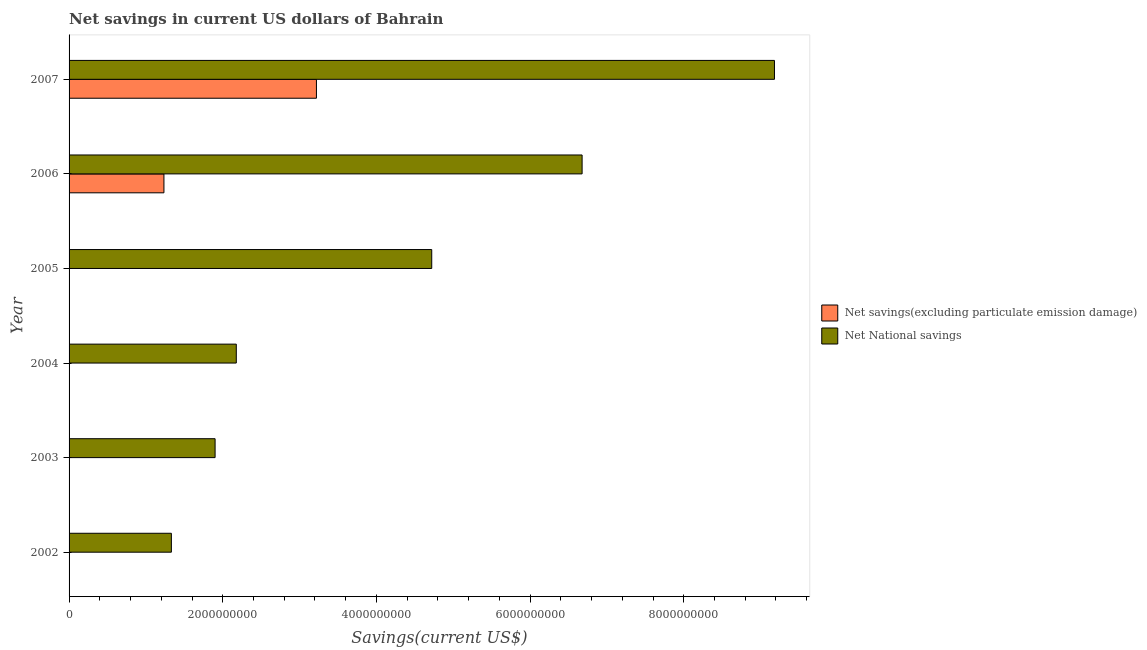How many bars are there on the 3rd tick from the top?
Offer a terse response. 1. How many bars are there on the 1st tick from the bottom?
Your answer should be compact. 1. In how many cases, is the number of bars for a given year not equal to the number of legend labels?
Give a very brief answer. 4. What is the net national savings in 2004?
Keep it short and to the point. 2.18e+09. Across all years, what is the maximum net savings(excluding particulate emission damage)?
Give a very brief answer. 3.22e+09. Across all years, what is the minimum net savings(excluding particulate emission damage)?
Make the answer very short. 0. What is the total net savings(excluding particulate emission damage) in the graph?
Your answer should be compact. 4.45e+09. What is the difference between the net national savings in 2002 and that in 2004?
Offer a very short reply. -8.45e+08. What is the difference between the net national savings in 2005 and the net savings(excluding particulate emission damage) in 2007?
Offer a terse response. 1.50e+09. What is the average net national savings per year?
Make the answer very short. 4.33e+09. What is the ratio of the net national savings in 2003 to that in 2007?
Your answer should be compact. 0.21. Is the difference between the net national savings in 2006 and 2007 greater than the difference between the net savings(excluding particulate emission damage) in 2006 and 2007?
Your answer should be compact. No. What is the difference between the highest and the second highest net national savings?
Make the answer very short. 2.50e+09. What is the difference between the highest and the lowest net savings(excluding particulate emission damage)?
Keep it short and to the point. 3.22e+09. In how many years, is the net national savings greater than the average net national savings taken over all years?
Your answer should be compact. 3. Is the sum of the net national savings in 2003 and 2004 greater than the maximum net savings(excluding particulate emission damage) across all years?
Give a very brief answer. Yes. How many bars are there?
Offer a terse response. 8. Are all the bars in the graph horizontal?
Offer a terse response. Yes. How many years are there in the graph?
Give a very brief answer. 6. Are the values on the major ticks of X-axis written in scientific E-notation?
Your answer should be compact. No. Does the graph contain grids?
Ensure brevity in your answer.  No. Where does the legend appear in the graph?
Give a very brief answer. Center right. How many legend labels are there?
Your response must be concise. 2. How are the legend labels stacked?
Offer a terse response. Vertical. What is the title of the graph?
Provide a short and direct response. Net savings in current US dollars of Bahrain. Does "Lowest 20% of population" appear as one of the legend labels in the graph?
Provide a short and direct response. No. What is the label or title of the X-axis?
Provide a short and direct response. Savings(current US$). What is the Savings(current US$) in Net savings(excluding particulate emission damage) in 2002?
Keep it short and to the point. 0. What is the Savings(current US$) of Net National savings in 2002?
Provide a succinct answer. 1.33e+09. What is the Savings(current US$) in Net savings(excluding particulate emission damage) in 2003?
Your answer should be compact. 0. What is the Savings(current US$) in Net National savings in 2003?
Provide a short and direct response. 1.90e+09. What is the Savings(current US$) in Net savings(excluding particulate emission damage) in 2004?
Ensure brevity in your answer.  0. What is the Savings(current US$) of Net National savings in 2004?
Provide a short and direct response. 2.18e+09. What is the Savings(current US$) in Net savings(excluding particulate emission damage) in 2005?
Offer a terse response. 0. What is the Savings(current US$) in Net National savings in 2005?
Ensure brevity in your answer.  4.72e+09. What is the Savings(current US$) in Net savings(excluding particulate emission damage) in 2006?
Your response must be concise. 1.23e+09. What is the Savings(current US$) in Net National savings in 2006?
Give a very brief answer. 6.68e+09. What is the Savings(current US$) in Net savings(excluding particulate emission damage) in 2007?
Offer a very short reply. 3.22e+09. What is the Savings(current US$) in Net National savings in 2007?
Keep it short and to the point. 9.18e+09. Across all years, what is the maximum Savings(current US$) of Net savings(excluding particulate emission damage)?
Your answer should be compact. 3.22e+09. Across all years, what is the maximum Savings(current US$) in Net National savings?
Your answer should be compact. 9.18e+09. Across all years, what is the minimum Savings(current US$) of Net savings(excluding particulate emission damage)?
Make the answer very short. 0. Across all years, what is the minimum Savings(current US$) of Net National savings?
Your answer should be compact. 1.33e+09. What is the total Savings(current US$) in Net savings(excluding particulate emission damage) in the graph?
Provide a succinct answer. 4.45e+09. What is the total Savings(current US$) of Net National savings in the graph?
Make the answer very short. 2.60e+1. What is the difference between the Savings(current US$) in Net National savings in 2002 and that in 2003?
Offer a very short reply. -5.69e+08. What is the difference between the Savings(current US$) in Net National savings in 2002 and that in 2004?
Offer a very short reply. -8.45e+08. What is the difference between the Savings(current US$) of Net National savings in 2002 and that in 2005?
Your response must be concise. -3.39e+09. What is the difference between the Savings(current US$) in Net National savings in 2002 and that in 2006?
Your response must be concise. -5.35e+09. What is the difference between the Savings(current US$) in Net National savings in 2002 and that in 2007?
Provide a short and direct response. -7.85e+09. What is the difference between the Savings(current US$) of Net National savings in 2003 and that in 2004?
Make the answer very short. -2.76e+08. What is the difference between the Savings(current US$) in Net National savings in 2003 and that in 2005?
Your response must be concise. -2.82e+09. What is the difference between the Savings(current US$) in Net National savings in 2003 and that in 2006?
Keep it short and to the point. -4.78e+09. What is the difference between the Savings(current US$) in Net National savings in 2003 and that in 2007?
Keep it short and to the point. -7.28e+09. What is the difference between the Savings(current US$) of Net National savings in 2004 and that in 2005?
Keep it short and to the point. -2.54e+09. What is the difference between the Savings(current US$) in Net National savings in 2004 and that in 2006?
Offer a very short reply. -4.50e+09. What is the difference between the Savings(current US$) in Net National savings in 2004 and that in 2007?
Your answer should be very brief. -7.00e+09. What is the difference between the Savings(current US$) in Net National savings in 2005 and that in 2006?
Make the answer very short. -1.96e+09. What is the difference between the Savings(current US$) of Net National savings in 2005 and that in 2007?
Offer a terse response. -4.46e+09. What is the difference between the Savings(current US$) in Net savings(excluding particulate emission damage) in 2006 and that in 2007?
Ensure brevity in your answer.  -1.98e+09. What is the difference between the Savings(current US$) of Net National savings in 2006 and that in 2007?
Ensure brevity in your answer.  -2.50e+09. What is the difference between the Savings(current US$) of Net savings(excluding particulate emission damage) in 2006 and the Savings(current US$) of Net National savings in 2007?
Make the answer very short. -7.95e+09. What is the average Savings(current US$) of Net savings(excluding particulate emission damage) per year?
Your response must be concise. 7.42e+08. What is the average Savings(current US$) of Net National savings per year?
Your answer should be compact. 4.33e+09. In the year 2006, what is the difference between the Savings(current US$) in Net savings(excluding particulate emission damage) and Savings(current US$) in Net National savings?
Provide a succinct answer. -5.44e+09. In the year 2007, what is the difference between the Savings(current US$) of Net savings(excluding particulate emission damage) and Savings(current US$) of Net National savings?
Give a very brief answer. -5.96e+09. What is the ratio of the Savings(current US$) in Net National savings in 2002 to that in 2003?
Keep it short and to the point. 0.7. What is the ratio of the Savings(current US$) in Net National savings in 2002 to that in 2004?
Offer a terse response. 0.61. What is the ratio of the Savings(current US$) in Net National savings in 2002 to that in 2005?
Keep it short and to the point. 0.28. What is the ratio of the Savings(current US$) in Net National savings in 2002 to that in 2006?
Make the answer very short. 0.2. What is the ratio of the Savings(current US$) in Net National savings in 2002 to that in 2007?
Ensure brevity in your answer.  0.14. What is the ratio of the Savings(current US$) in Net National savings in 2003 to that in 2004?
Give a very brief answer. 0.87. What is the ratio of the Savings(current US$) in Net National savings in 2003 to that in 2005?
Provide a short and direct response. 0.4. What is the ratio of the Savings(current US$) in Net National savings in 2003 to that in 2006?
Your answer should be compact. 0.28. What is the ratio of the Savings(current US$) of Net National savings in 2003 to that in 2007?
Give a very brief answer. 0.21. What is the ratio of the Savings(current US$) in Net National savings in 2004 to that in 2005?
Keep it short and to the point. 0.46. What is the ratio of the Savings(current US$) of Net National savings in 2004 to that in 2006?
Your answer should be compact. 0.33. What is the ratio of the Savings(current US$) of Net National savings in 2004 to that in 2007?
Ensure brevity in your answer.  0.24. What is the ratio of the Savings(current US$) in Net National savings in 2005 to that in 2006?
Provide a succinct answer. 0.71. What is the ratio of the Savings(current US$) in Net National savings in 2005 to that in 2007?
Give a very brief answer. 0.51. What is the ratio of the Savings(current US$) of Net savings(excluding particulate emission damage) in 2006 to that in 2007?
Keep it short and to the point. 0.38. What is the ratio of the Savings(current US$) of Net National savings in 2006 to that in 2007?
Your response must be concise. 0.73. What is the difference between the highest and the second highest Savings(current US$) of Net National savings?
Make the answer very short. 2.50e+09. What is the difference between the highest and the lowest Savings(current US$) of Net savings(excluding particulate emission damage)?
Keep it short and to the point. 3.22e+09. What is the difference between the highest and the lowest Savings(current US$) in Net National savings?
Offer a very short reply. 7.85e+09. 